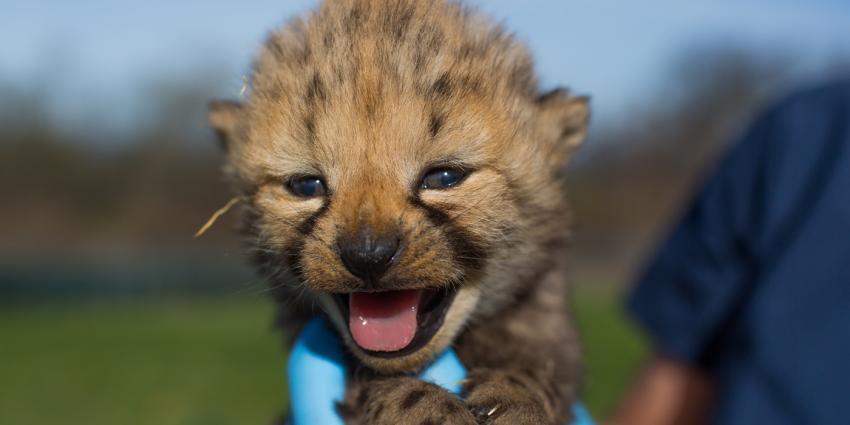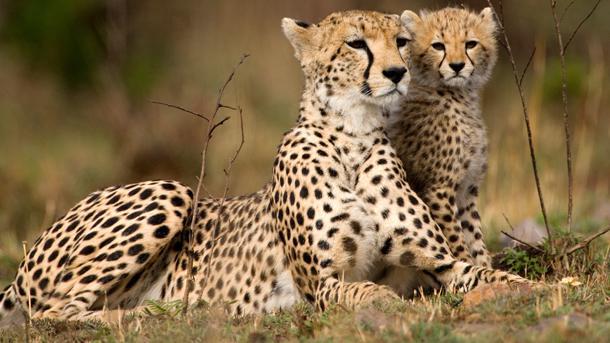The first image is the image on the left, the second image is the image on the right. Assess this claim about the two images: "An image contains exactly one cheetah.". Correct or not? Answer yes or no. Yes. The first image is the image on the left, the second image is the image on the right. For the images displayed, is the sentence "The combined images include at least one adult cheetah and at least six fuzzy-headed baby cheetahs." factually correct? Answer yes or no. No. 